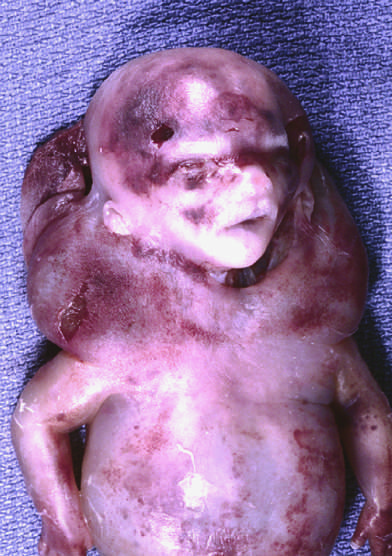has a nucleolar pattern been termed cystic hygroma?
Answer the question using a single word or phrase. No 